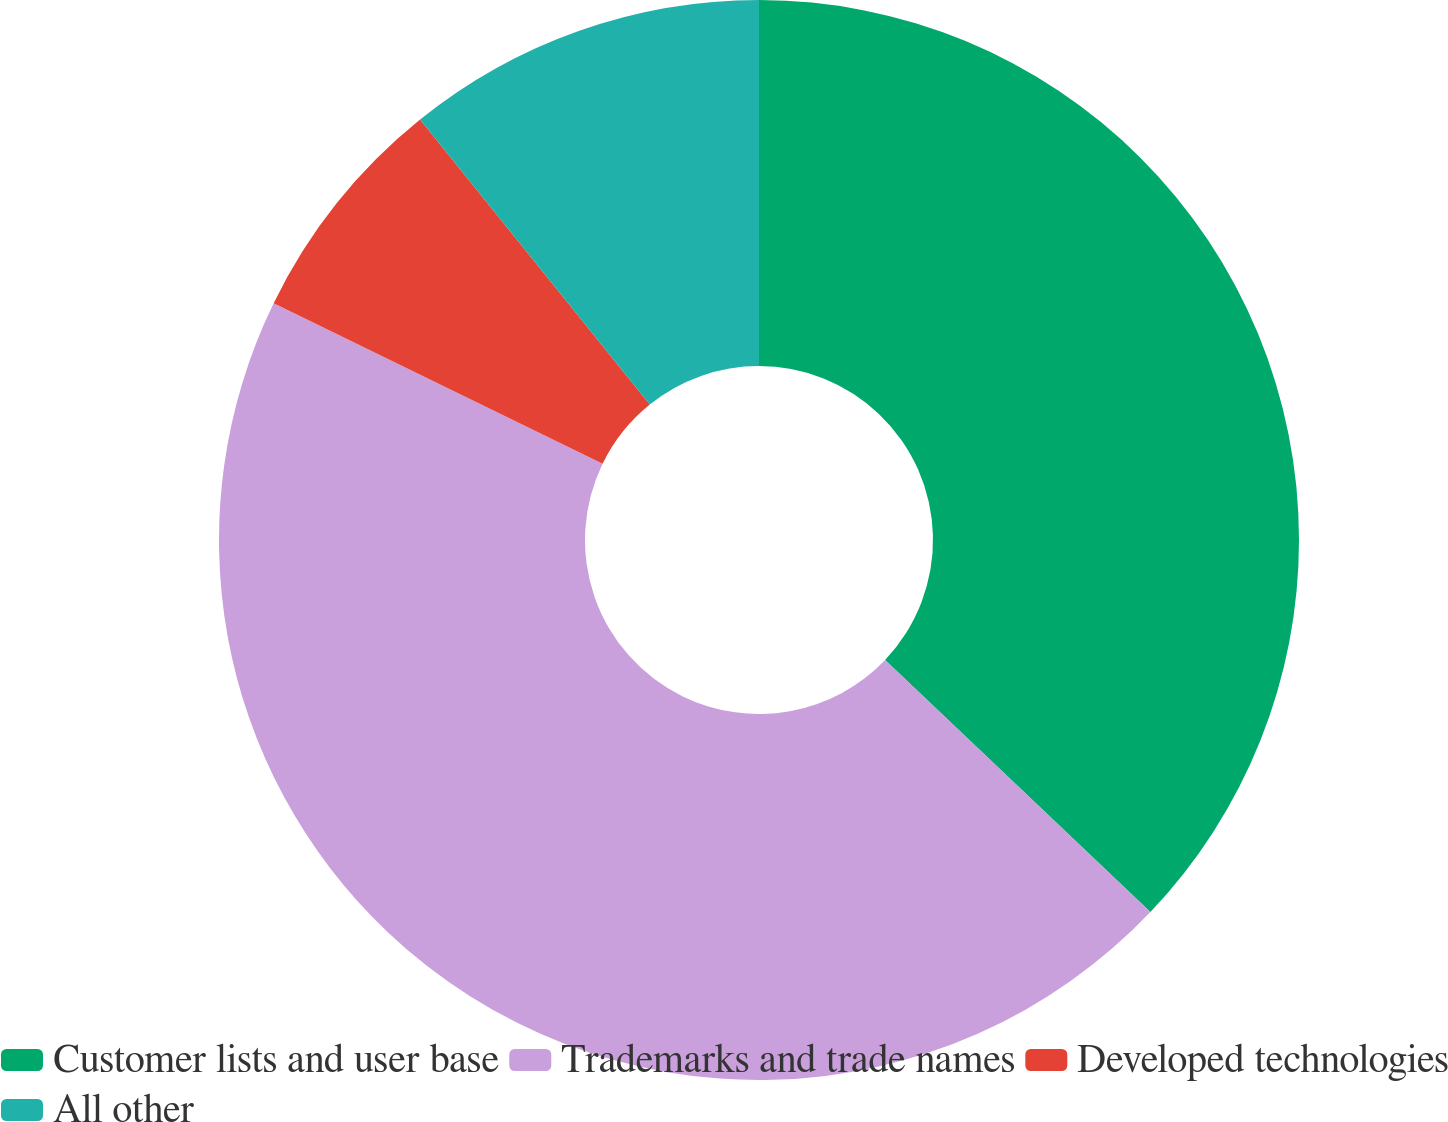Convert chart to OTSL. <chart><loc_0><loc_0><loc_500><loc_500><pie_chart><fcel>Customer lists and user base<fcel>Trademarks and trade names<fcel>Developed technologies<fcel>All other<nl><fcel>37.1%<fcel>45.13%<fcel>6.98%<fcel>10.8%<nl></chart> 